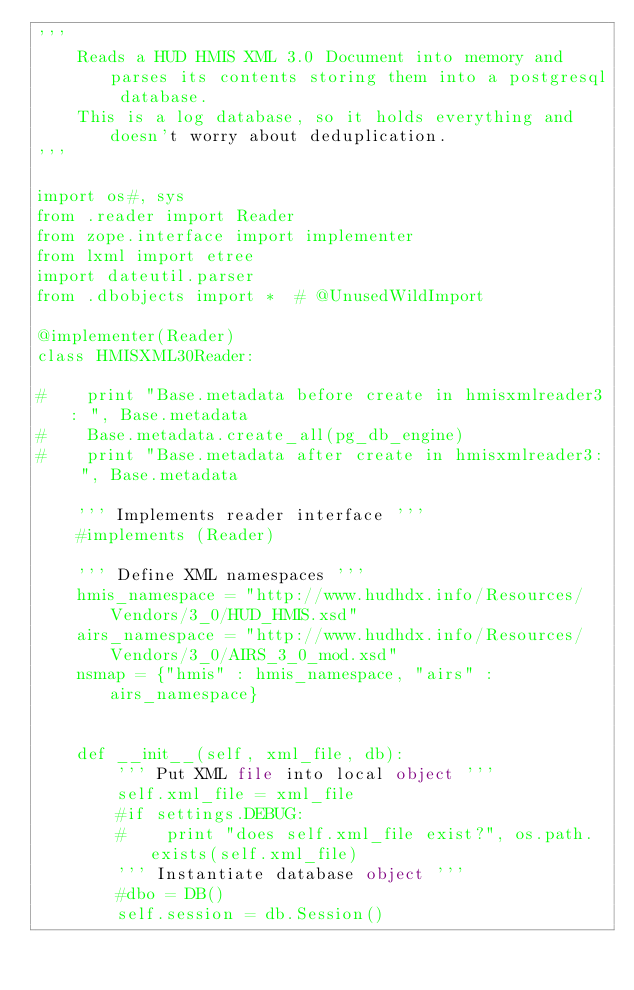Convert code to text. <code><loc_0><loc_0><loc_500><loc_500><_Python_>''' 
    Reads a HUD HMIS XML 3.0 Document into memory and parses its contents storing them into a postgresql database.
    This is a log database, so it holds everything and doesn't worry about deduplication.
'''

import os#, sys
from .reader import Reader
from zope.interface import implementer
from lxml import etree
import dateutil.parser
from .dbobjects import *  # @UnusedWildImport

@implementer(Reader)
class HMISXML30Reader: 
    
#    print "Base.metadata before create in hmisxmlreader3: ", Base.metadata
#    Base.metadata.create_all(pg_db_engine)
#    print "Base.metadata after create in hmisxmlreader3: ", Base.metadata

    ''' Implements reader interface '''
    #implements (Reader) 

    ''' Define XML namespaces '''
    hmis_namespace = "http://www.hudhdx.info/Resources/Vendors/3_0/HUD_HMIS.xsd" 
    airs_namespace = "http://www.hudhdx.info/Resources/Vendors/3_0/AIRS_3_0_mod.xsd"
    nsmap = {"hmis" : hmis_namespace, "airs" : airs_namespace}


    def __init__(self, xml_file, db):
        ''' Put XML file into local object '''
        self.xml_file = xml_file
        #if settings.DEBUG:
        #    print "does self.xml_file exist?", os.path.exists(self.xml_file)
        ''' Instantiate database object '''
        #dbo = DB()
        self.session = db.Session()
</code> 